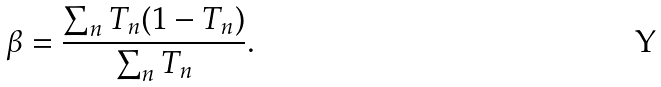<formula> <loc_0><loc_0><loc_500><loc_500>\beta = \frac { \sum _ { n } T _ { n } ( 1 - T _ { n } ) } { \sum _ { n } T _ { n } } .</formula> 